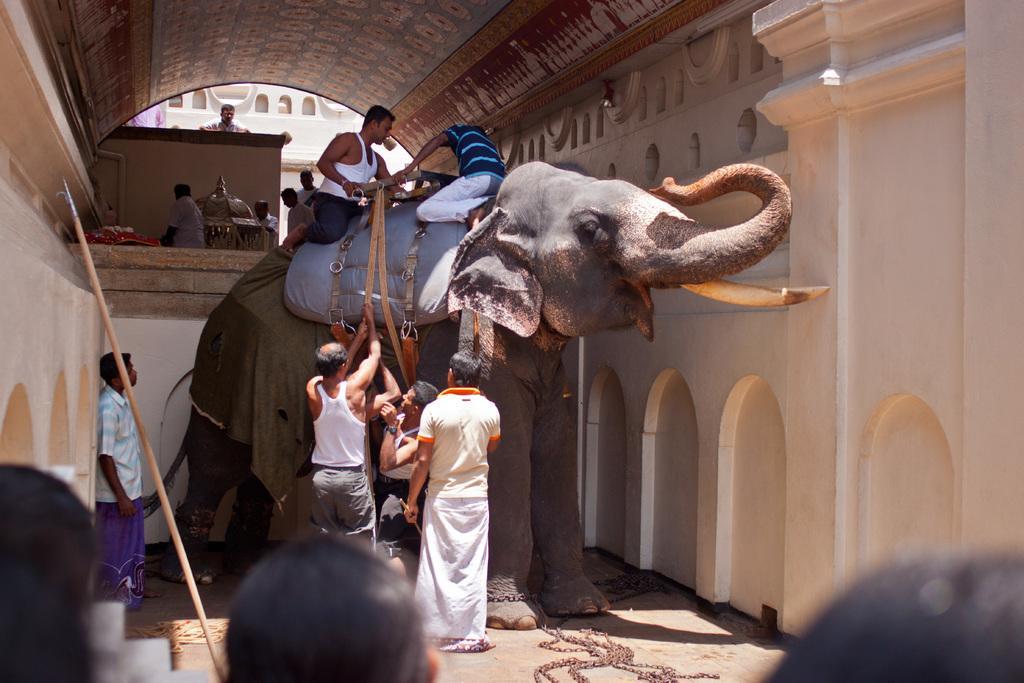In one or two sentences, can you explain what this image depicts? there is a elephant on the elephant there are two person sitting are many people near to the elephant and working. 